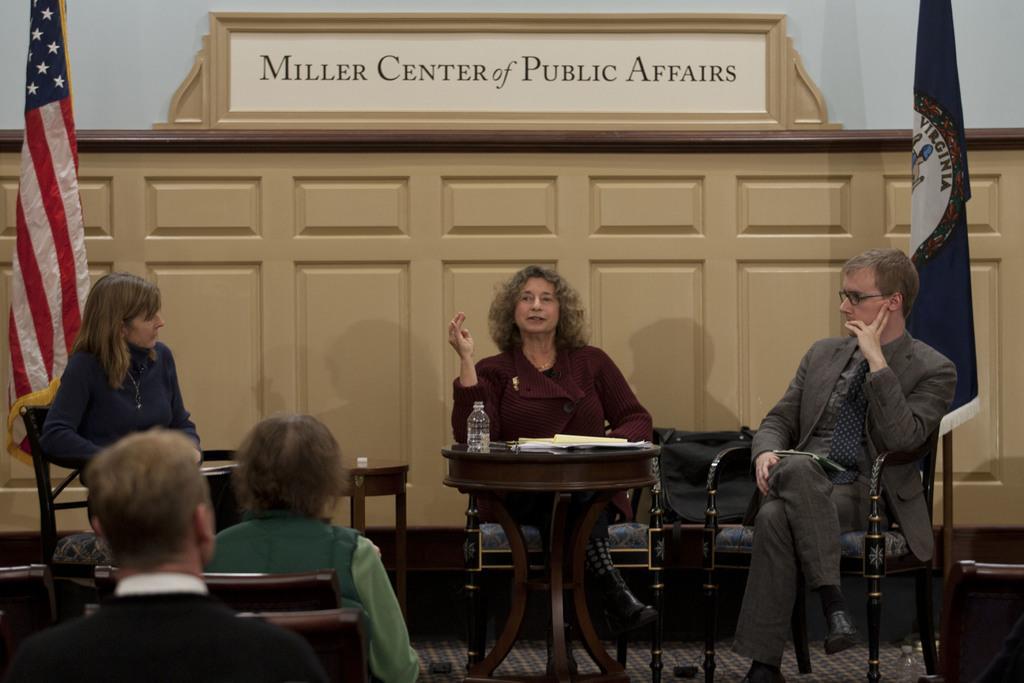In one or two sentences, can you explain what this image depicts? Here we can see five persons are sitting on the chairs. These are the tables. On the table there is a bottle, and a book. These are the flags. This is floor and there is a carpet. On the background there is a wall and this is board. 